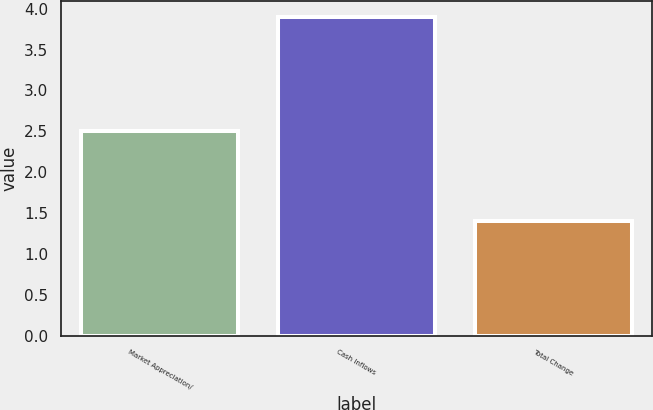Convert chart. <chart><loc_0><loc_0><loc_500><loc_500><bar_chart><fcel>Market Appreciation/<fcel>Cash Inflows<fcel>Total Change<nl><fcel>2.5<fcel>3.9<fcel>1.4<nl></chart> 